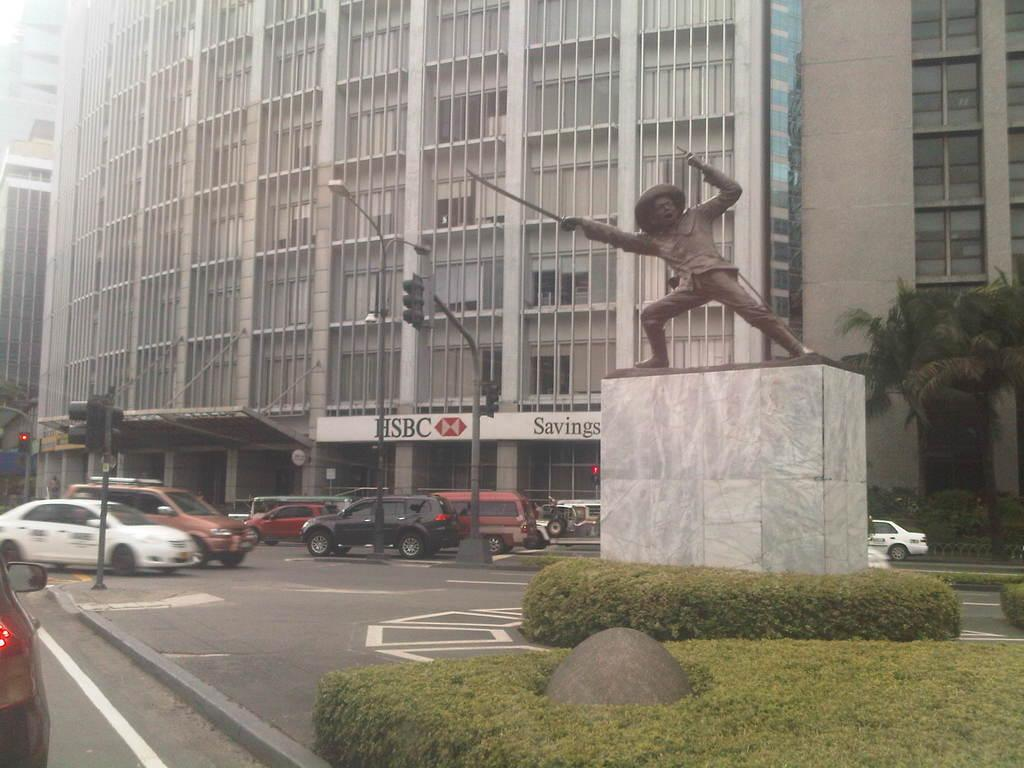What is the main subject of the image? The main subject of the image is a person's status on a platform. What type of vegetation can be seen in the image? There are plants and trees visible in the image. What can be seen on the road in the image? Vehicles are visible on the road in the image. What type of structures are present in the image? There are buildings in the image. What feature is present on the buildings in the image? Windows are present in the image. What is written on the wall in the image? There is a name board on a wall in the image. What type of vest is the person wearing in the image? There is no vest visible in the image; the person's status on the platform is the main focus. 